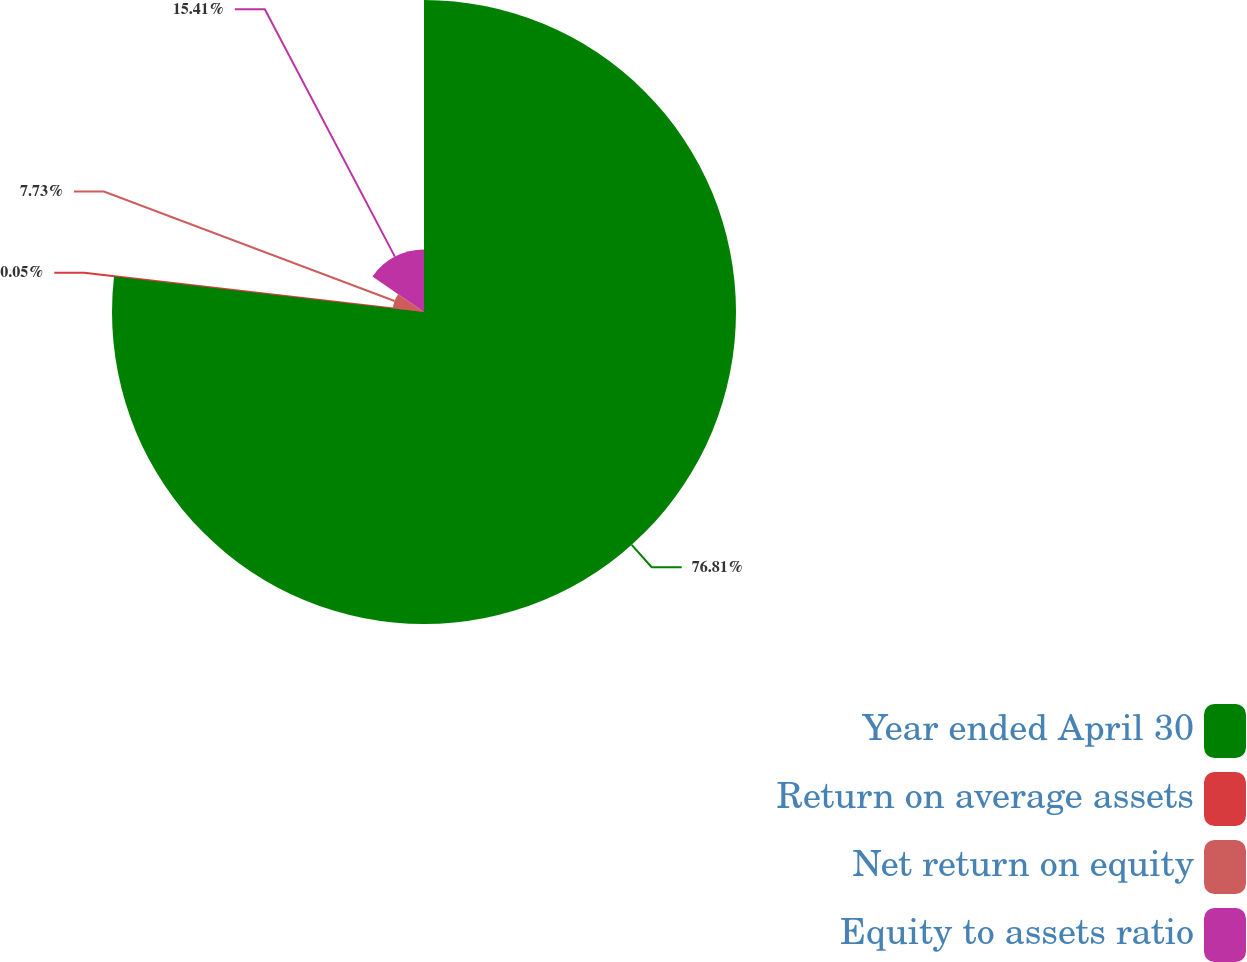<chart> <loc_0><loc_0><loc_500><loc_500><pie_chart><fcel>Year ended April 30<fcel>Return on average assets<fcel>Net return on equity<fcel>Equity to assets ratio<nl><fcel>76.81%<fcel>0.05%<fcel>7.73%<fcel>15.41%<nl></chart> 